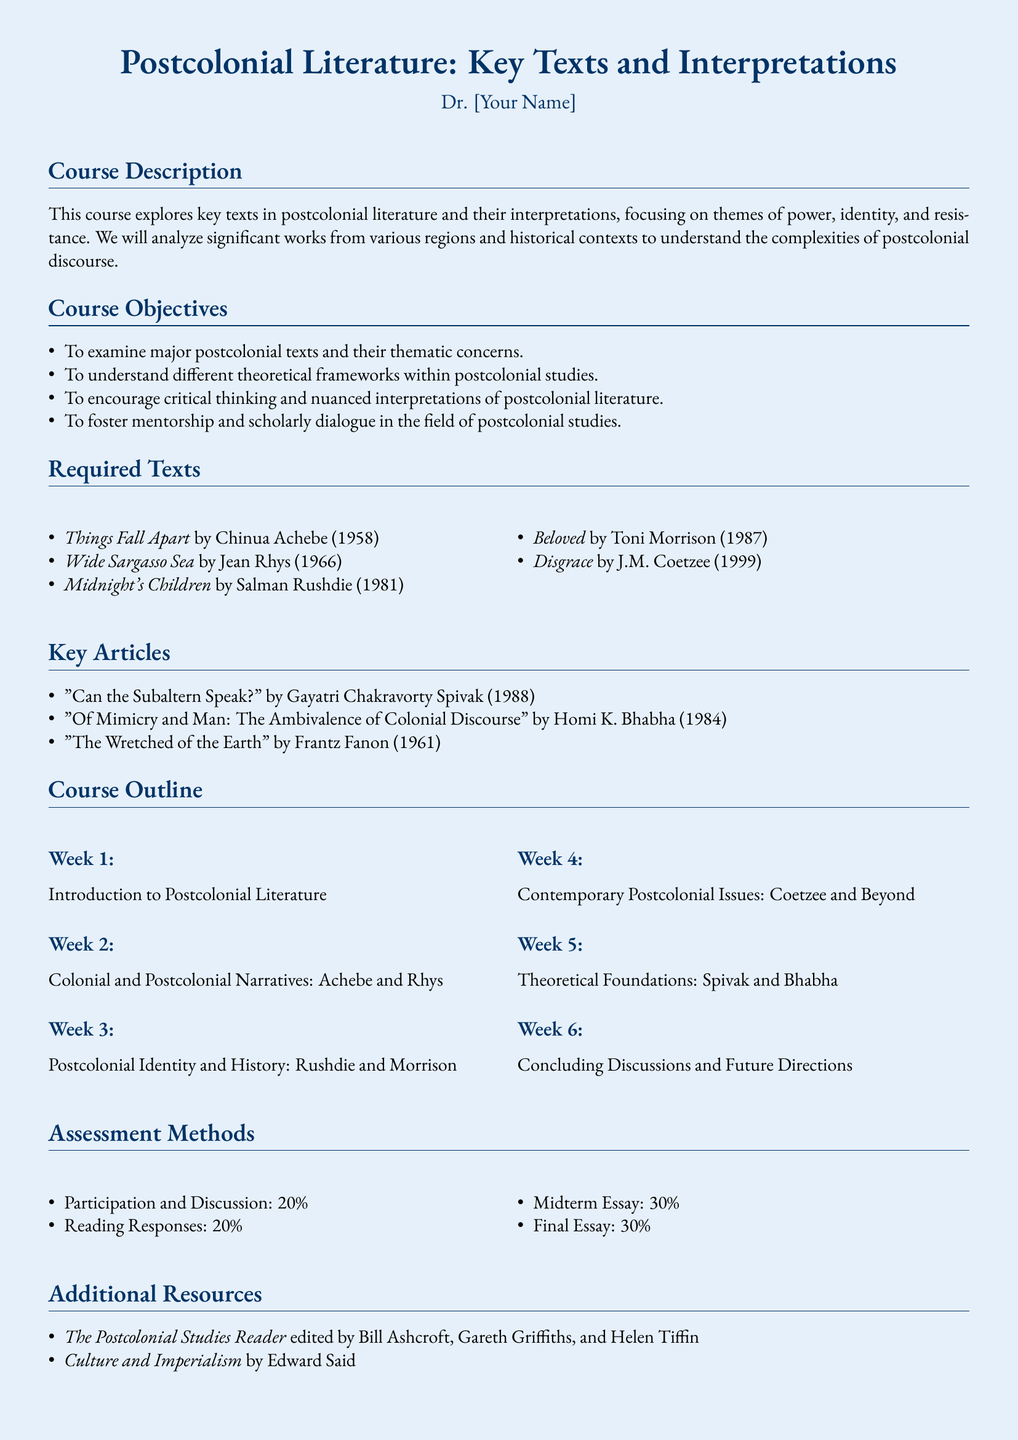What is the course title? The course title is found at the top of the syllabus.
Answer: Postcolonial Literature: Key Texts and Interpretations Who is the instructor? The instructor's name is indicated below the course title.
Answer: Dr. [Your Name] What percentage of the grade is the midterm essay? The midterm essay's contribution to the overall grade is outlined in the assessment methods.
Answer: 30% Which text is written by Toni Morrison? The required texts list includes the author and title.
Answer: Beloved What is the focus of Week 1 in the course outline? The topic for Week 1 is included in the course outline section.
Answer: Introduction to Postcolonial Literature Name one key article by Homi K. Bhabha. The key articles section lists the titles and authors of significant works.
Answer: Of Mimicry and Man: The Ambivalence of Colonial Discourse What type of assignments are included in the assessment methods? The assessment methods describe the various types of evaluations for the course.
Answer: Reading Responses How many texts are listed in the required texts section? The required texts section provides a numbered list of texts.
Answer: 5 What are the two additional resources listed? The additional resources section specifies supplementary readings for the course.
Answer: The Postcolonial Studies Reader, Culture and Imperialism 